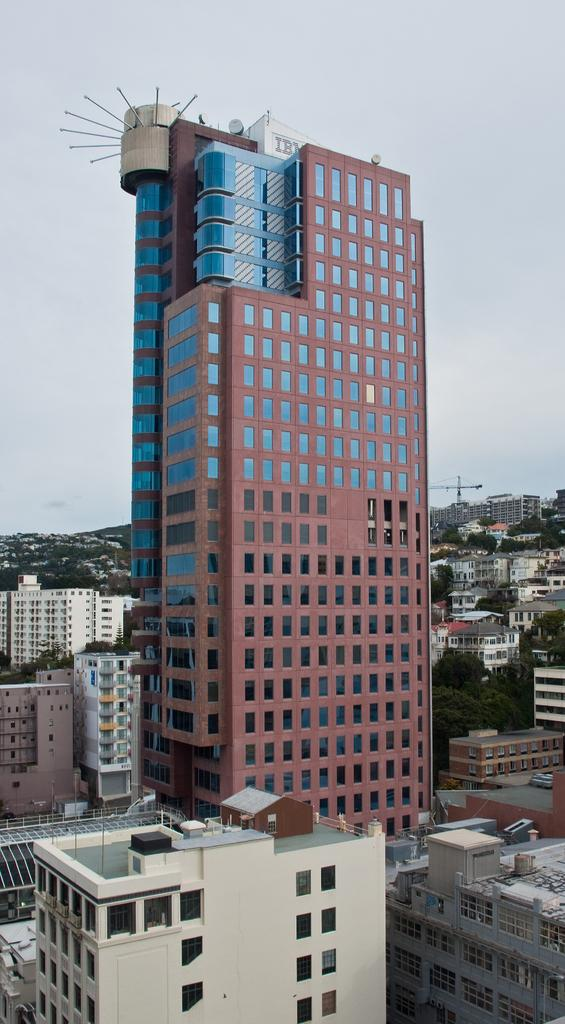What is the main structure in the center of the image? There is a skyscraper in the center of the image. What other structures can be seen in the image? There are buildings in the image. What type of vegetation is present in the image? There are trees in the image. What are the poles used for in the image? The purpose of the poles in the image is not specified, but they could be for streetlights, traffic signals, or other purposes. What type of pies are being sold in the town depicted in the image? There is no town or pie shop depicted in the image; it primarily features a skyscraper and other structures. 